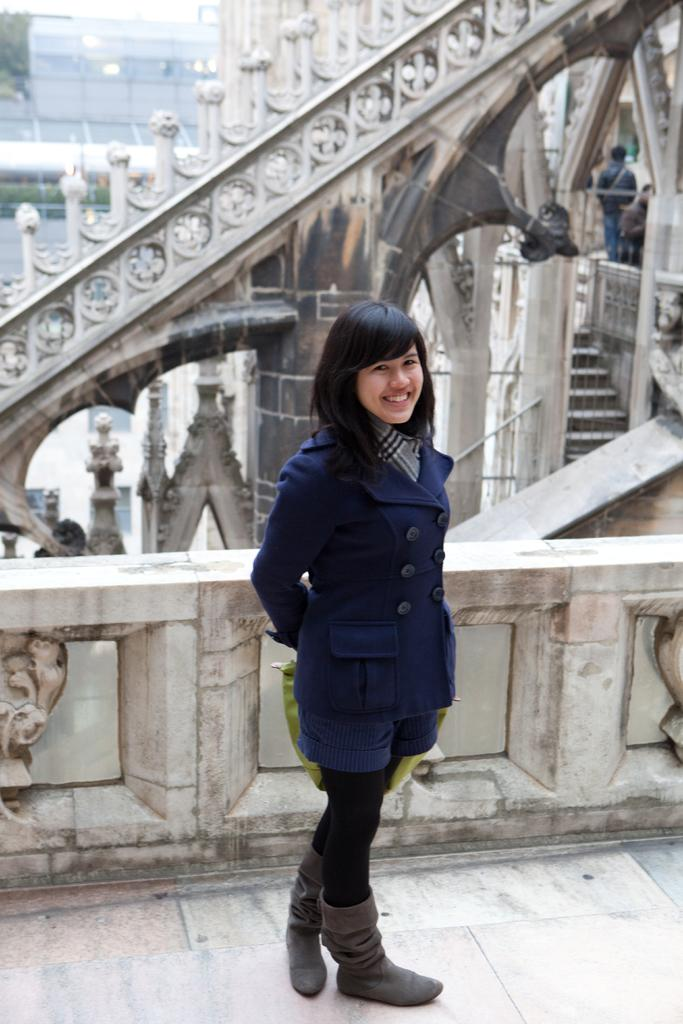Who is present in the image? There is a woman in the image. What is the woman wearing? The woman is wearing a blue coat. What is the woman's facial expression? The woman is smiling. What can be seen behind the woman? There is a railing behind the woman. What is visible in the background of the image? There is a building in the background of the image. What is the woman's temper like in the image? There is no indication of the woman's temper in the image; only her facial expression (smiling) is visible. 